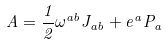<formula> <loc_0><loc_0><loc_500><loc_500>A = \frac { 1 } { 2 } \omega ^ { a b } J _ { a b } + e ^ { a } P _ { a }</formula> 